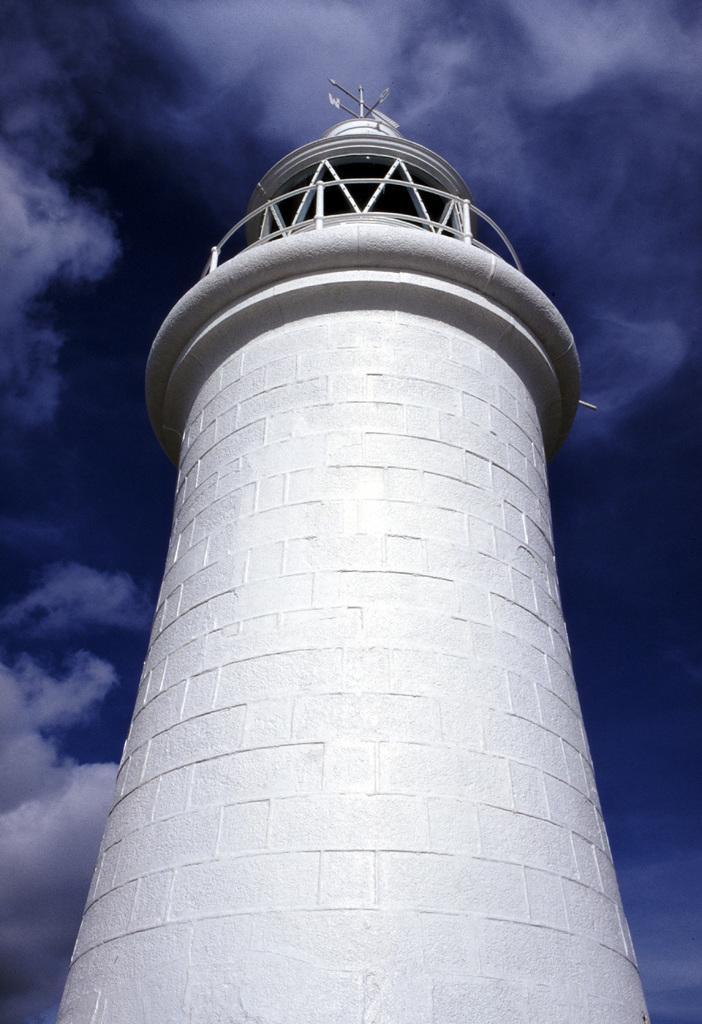In one or two sentences, can you explain what this image depicts? In the center of this picture we can see the tower and the metal rods and some other objects. In the background we can see the sky with the clouds. 